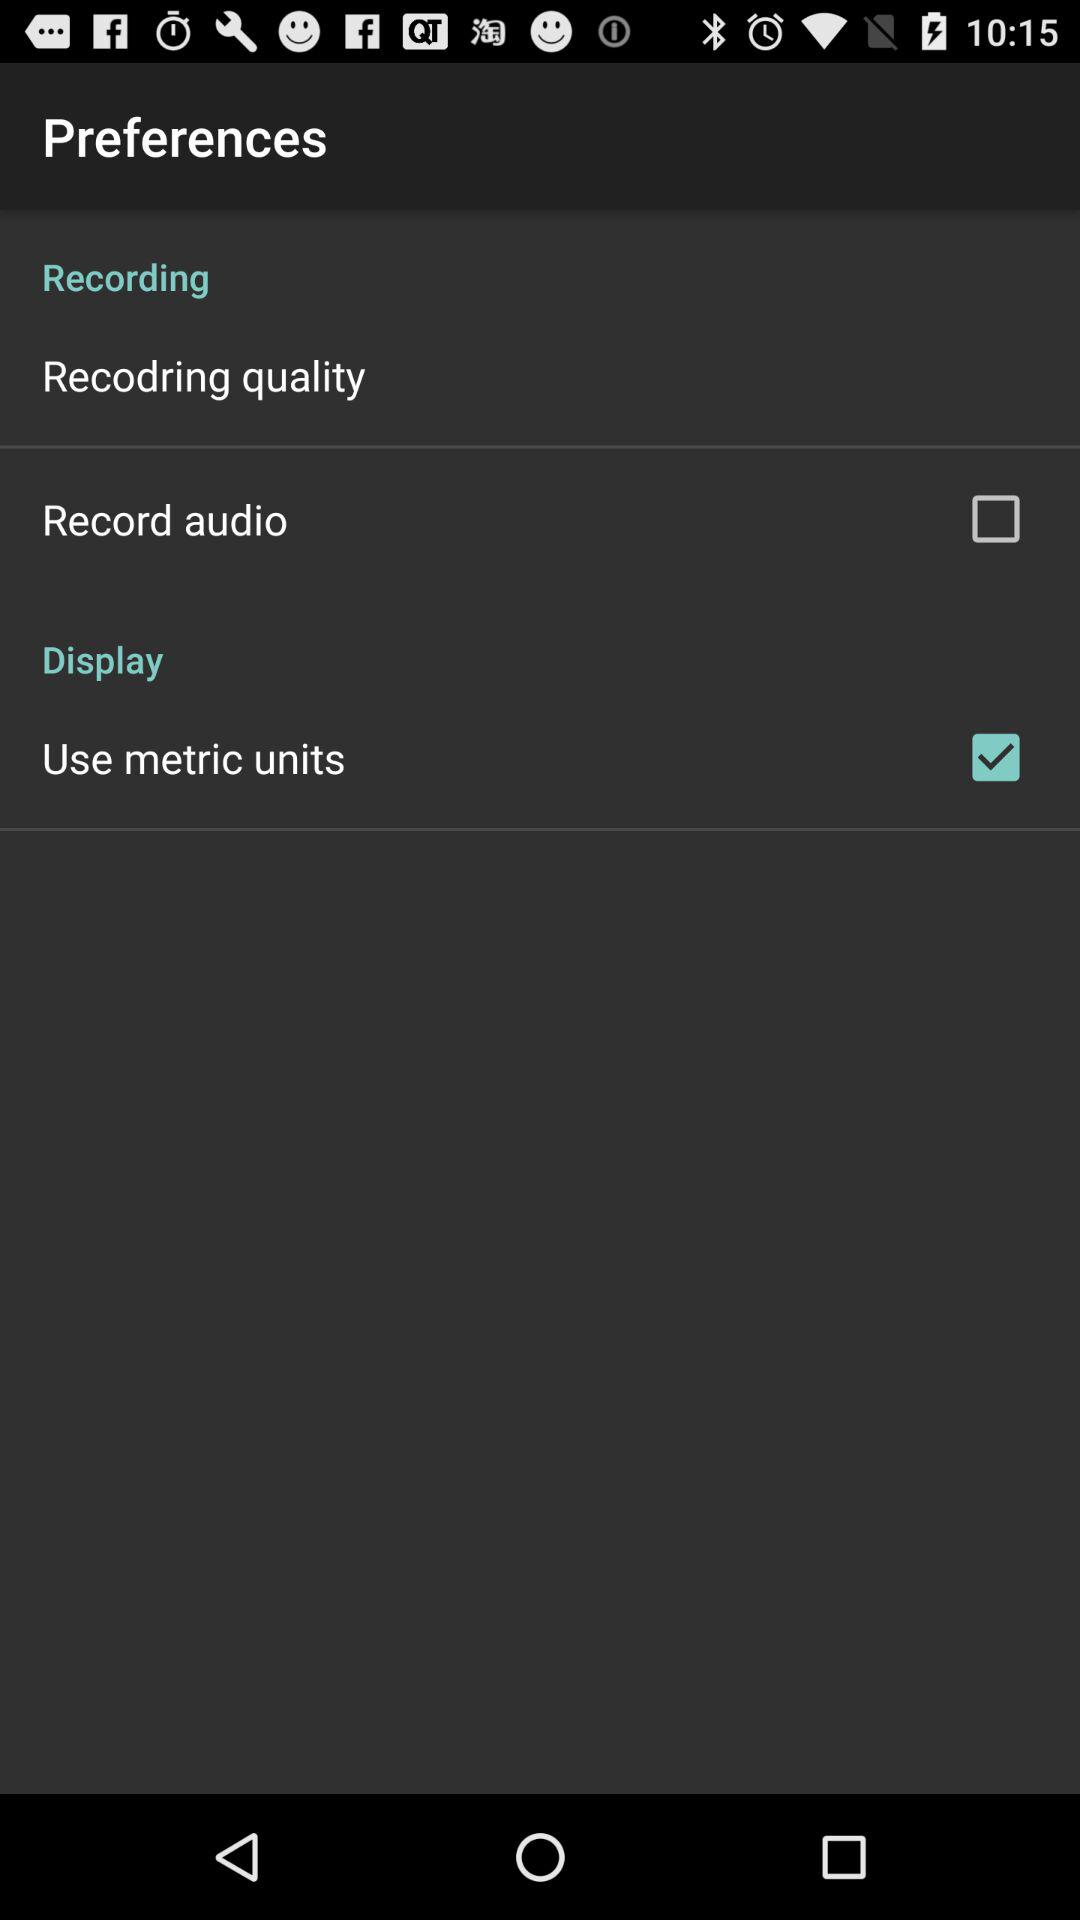How many items have a checkbox next to them?
Answer the question using a single word or phrase. 2 